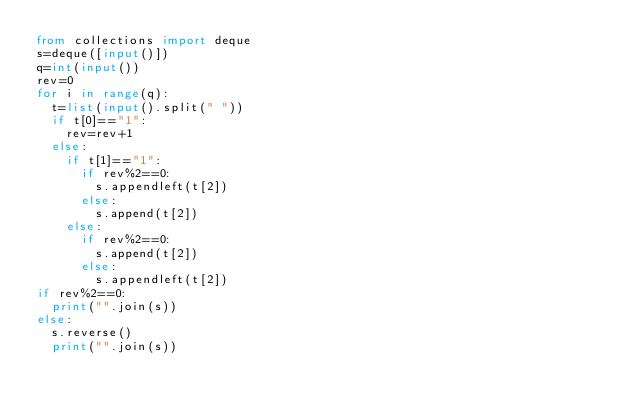<code> <loc_0><loc_0><loc_500><loc_500><_Python_>from collections import deque
s=deque([input()])
q=int(input())
rev=0
for i in range(q):
  t=list(input().split(" "))
  if t[0]=="1":
    rev=rev+1
  else:
    if t[1]=="1":
      if rev%2==0:
        s.appendleft(t[2])
      else:
        s.append(t[2])
    else:
      if rev%2==0:
        s.append(t[2])
      else:
        s.appendleft(t[2])
if rev%2==0:
  print("".join(s))
else:
  s.reverse()
  print("".join(s))</code> 